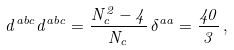<formula> <loc_0><loc_0><loc_500><loc_500>d ^ { a b c } d ^ { a b c } = \frac { N _ { c } ^ { 2 } - 4 } { N _ { c } } \, \delta ^ { a a } = \frac { 4 0 } { 3 } \, ,</formula> 